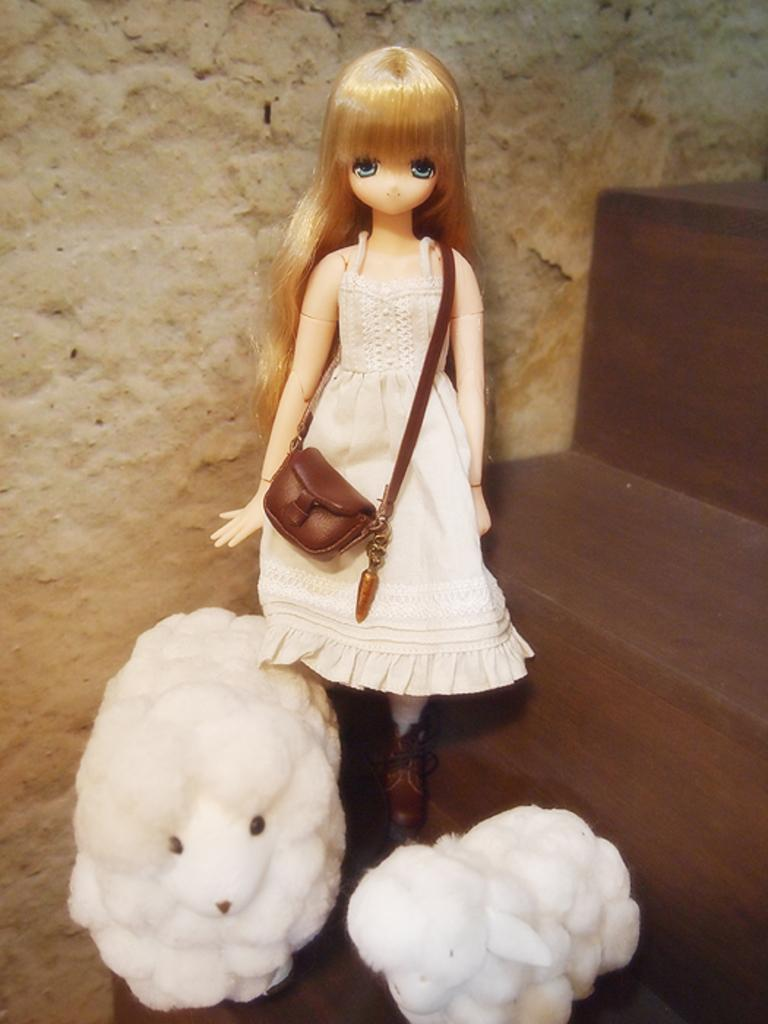Who is the main subject in the image? There is a girl in the image. What is the girl doing in the image? The girl is standing on wooden steps. Are there any animals in the image? Yes, there are two sheep at the bottom of the image. What can be seen in the background of the image? There is a wall in the background of the image. Where are the wooden steps located in the image? There are wooden steps on the right side of the image. What type of honey is being discussed by the girl and the sheep in the image? There is no indication in the image that the girl and the sheep are discussing honey or any other topic. 